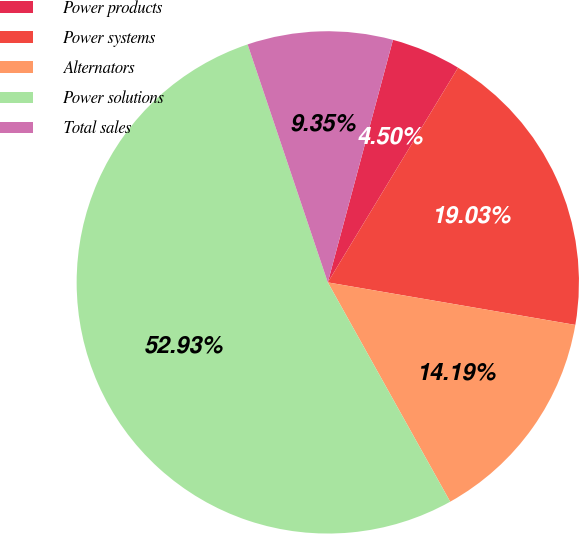Convert chart. <chart><loc_0><loc_0><loc_500><loc_500><pie_chart><fcel>Power products<fcel>Power systems<fcel>Alternators<fcel>Power solutions<fcel>Total sales<nl><fcel>4.5%<fcel>19.03%<fcel>14.19%<fcel>52.93%<fcel>9.35%<nl></chart> 